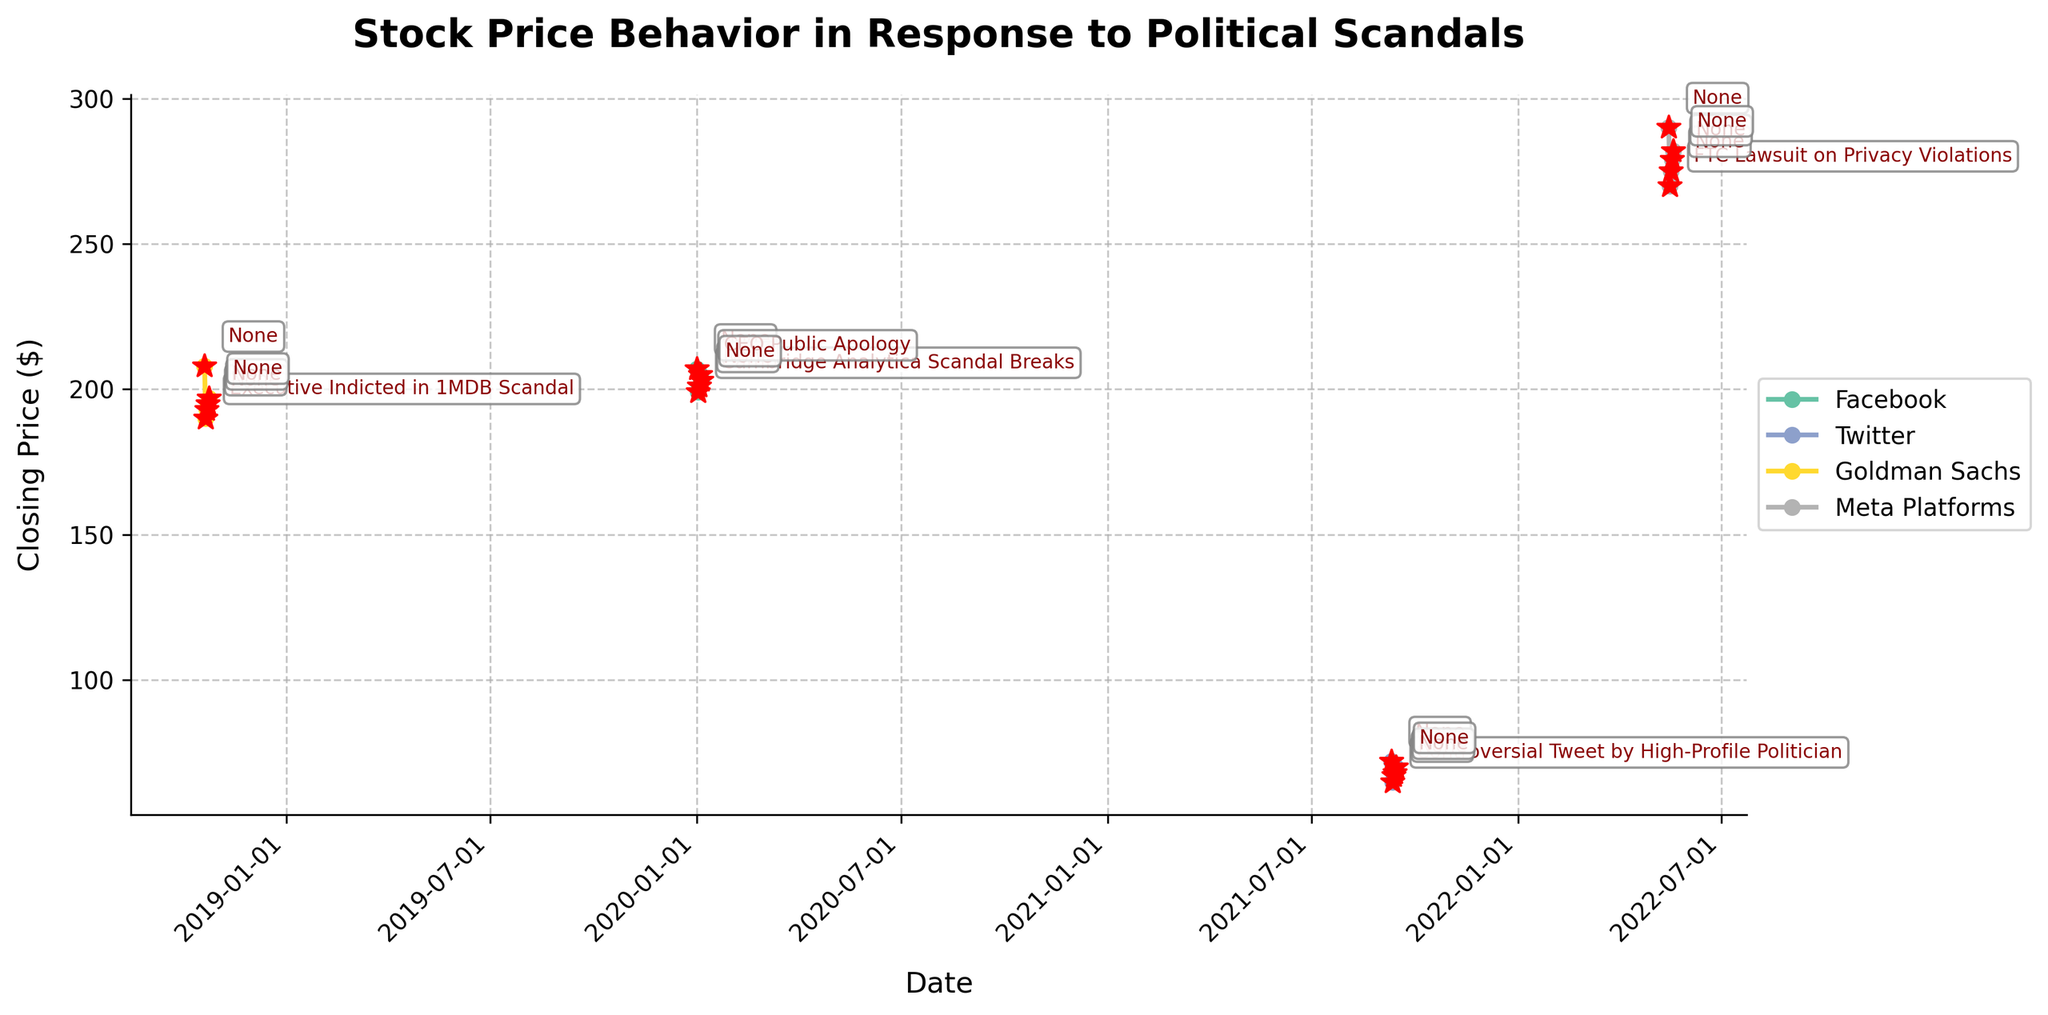what is the title of the figure? The title is found at the top of the figure, usually in a larger and bolder font than other text elements. It provides a summary of the figure's content or purpose.
Answer: Stock Price Behavior in Response to Political Scandals What are the companies featured in the plot? The company names are typically found in the legend of the plot, which is often located on the right side of the figure.
Answer: Facebook, Twitter, Goldman Sachs, Meta Platforms How does the stock price of Facebook change on January 2, 2020? By looking at the date January 2nd, 2020 on the x-axis and observing the corresponding y-axis value, we can see how the stock price changes. The Closing Price shows a drop from the previous day.
Answer: It drops Which company shows the most significant stock price drop after a scandalous event? The figure highlights notable events with red markers. By comparing the visible drops in stock price after these markers, we observe which company has the steepest decline immediately following a scandal.
Answer: Goldman Sachs On which date does Meta Platforms experience a significant event, and what happens to its stock price? The red marker indicating an important event and the associated annotation on the figure point to the date and event specifics. By tracing the x-axis to this point, we can observe the closing price before and after the event.
Answer: May 16, 2022; it drops What happens to Twitter's stock price the day after a controversial tweet by a high-profile politician on September 11, 2021? By identifying the date of the event (September 11, 2021) and observing the following day's stock price behavior, we can see any changes in the closing price.
Answer: The stock price rises How long does it typically take for stock prices to stabilize after a scandalous event? By analyzing multiple instances of scandalous events marked with red markers and observing the subsequent stock price trends over the following days, we can estimate the stabilization period.
Answer: Approximately 2-3 days Which company has the highest closing stock price before any scandal occurs? By identifying the closing prices just before the first scandal marked for each company, we can compare these values to determine the highest.
Answer: Meta Platforms ($300) Between Facebook's Cambridge Analytica scandal and CEO public apology, how does the stock price trend? Identify the dates of these two events for Facebook and observe the changes in the line graph between these points to describe the trend.
Answer: The stock price initially drops and then rises For which company does a public apology seem to positively affect the stock price? Look for instances where a public apology is labeled on the graph and observe the stock price behavior immediately following the apology event marker.
Answer: Facebook 